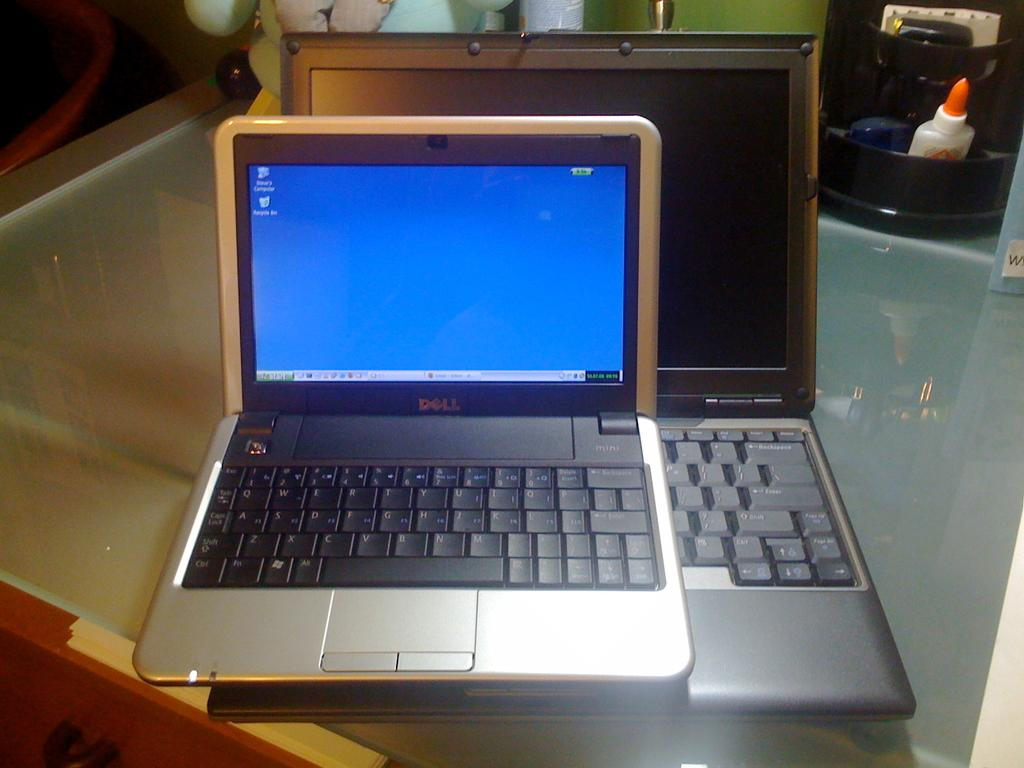Provide a one-sentence caption for the provided image. An old Dell computer sits on top of another computer. 